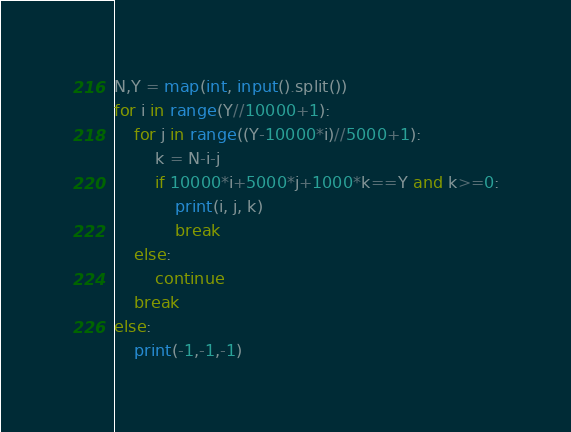<code> <loc_0><loc_0><loc_500><loc_500><_Python_>N,Y = map(int, input().split())
for i in range(Y//10000+1):
    for j in range((Y-10000*i)//5000+1):
        k = N-i-j
        if 10000*i+5000*j+1000*k==Y and k>=0:
            print(i, j, k)
            break
    else: 
        continue
    break
else:
    print(-1,-1,-1)</code> 